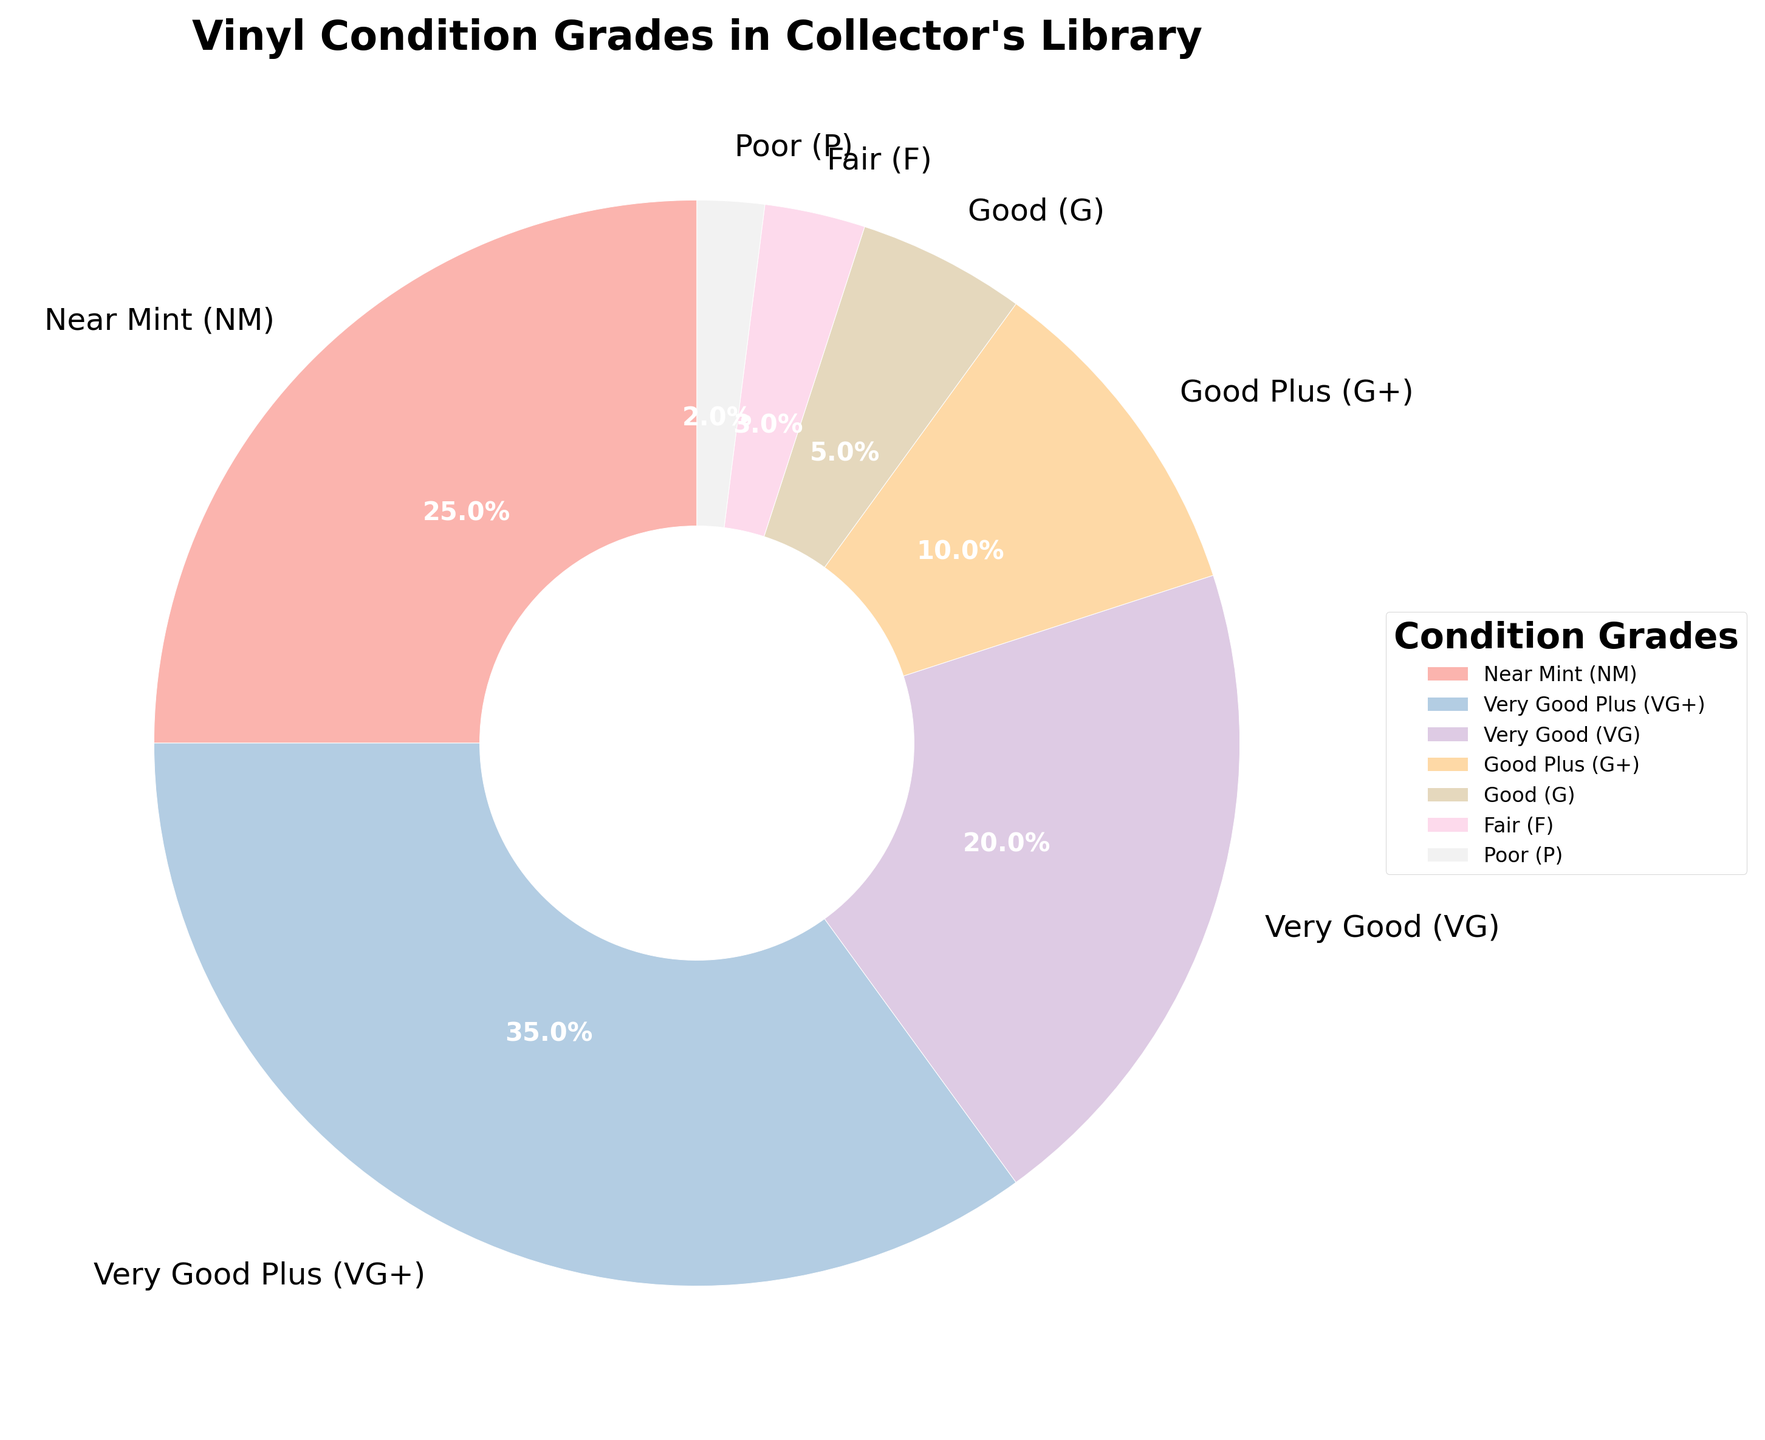What percentage of the vinyl is in Good Plus (G+) condition? The pie chart shows that the segment for Good Plus (G+) is labeled with its percentage.
Answer: 10% What is the sum of percentages of Near Mint (NM) and Very Good Plus (VG+) vinyl records? The figure shows NM is 25% and VG+ is 35%. Adding these two values gives 25 + 35.
Answer: 60% Which condition grade has the smallest percentage in the vinyl collection? The pie chart shows each segment's percentage. The smallest percentage is labeled Poor (P) with 2%.
Answer: Poor (P) Is the percentage of Very Good (VG) vinyls greater or less than the percentage of Near Mint (NM) vinyls? VG is 20% and NM is 25% as per the chart, so VG is less than NM.
Answer: Less What is the combined percentage of Good (G) and Fair (F) condition vinyls? The chart shows G with 5% and F with 3%. Adding these gives 5 + 3.
Answer: 8% What is the difference in percentage between Very Good Plus (VG+) and Good (G) condition vinyls? The chart shows VG+ is 35% and G is 5%. Subtracting these gives 35 - 5.
Answer: 30% Are there more vinyls in Good Plus (G+) condition or in Good (G) condition? The pie chart indicates G+ is 10% and G is 5%. G+ is greater than G.
Answer: Good Plus (G+) What is the percentage difference between the most and the least frequent condition grades? The chart shows the most frequent is VG+ at 35% and least frequent is P at 2%. Subtracting these, 35 - 2.
Answer: 33% What is the percentage of vinyls in acceptable condition (i.e., Very Good (VG) or better)? The chart shows VG (20%), VG+ (35%), and NM (25%). Summing these, 20 + 35 + 25.
Answer: 80% 